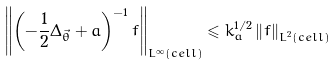Convert formula to latex. <formula><loc_0><loc_0><loc_500><loc_500>\left \| \left ( - \frac { 1 } { 2 } \Delta _ { \vec { \theta } } + a \right ) ^ { - 1 } f \right \| _ { L ^ { \infty } \left ( c e l l \right ) } \leqslant k _ { a } ^ { 1 / 2 } \left \| f \right \| _ { L ^ { 2 } \left ( c e l l \right ) }</formula> 